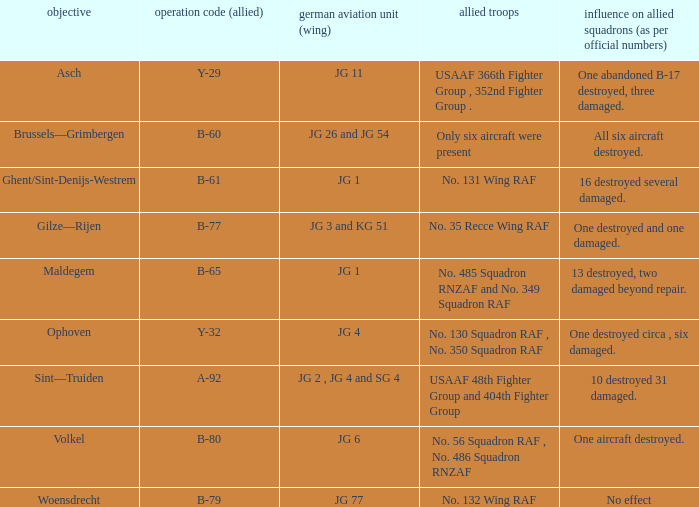What is the allied target code of the group that targetted ghent/sint-denijs-westrem? B-61. 